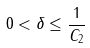<formula> <loc_0><loc_0><loc_500><loc_500>0 < \delta \leq \frac { 1 } { C _ { 2 } }</formula> 